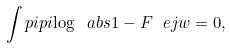Convert formula to latex. <formula><loc_0><loc_0><loc_500><loc_500>\int p i p i { \log \ a b s { 1 - F \ e j w } } = 0 ,</formula> 